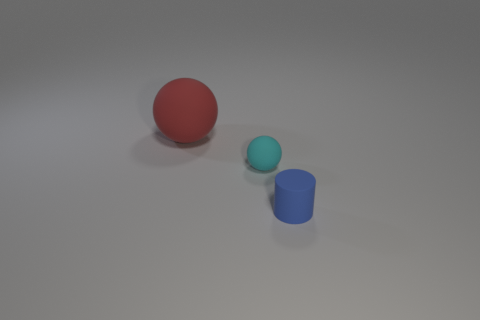Add 1 tiny matte things. How many objects exist? 4 Subtract all balls. How many objects are left? 1 Add 1 tiny cylinders. How many tiny cylinders are left? 2 Add 3 small blue rubber things. How many small blue rubber things exist? 4 Subtract 0 brown blocks. How many objects are left? 3 Subtract all cylinders. Subtract all small spheres. How many objects are left? 1 